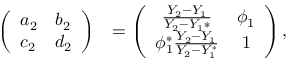Convert formula to latex. <formula><loc_0><loc_0><loc_500><loc_500>\begin{array} { r l } { \left ( \begin{array} { l l } { a _ { 2 } } & { b _ { 2 } } \\ { c _ { 2 } } & { d _ { 2 } } \end{array} \right ) } & { = \left ( \begin{array} { c c } { \frac { Y _ { 2 } - Y _ { 1 } } { Y _ { 2 } - Y _ { 1 } * } } & { \phi _ { 1 } } \\ { \phi _ { 1 } ^ { * } \frac { Y _ { 2 } - Y _ { 1 } } { Y _ { 2 } - Y _ { 1 } ^ { * } } } & { 1 } \end{array} \right ) , } \end{array}</formula> 